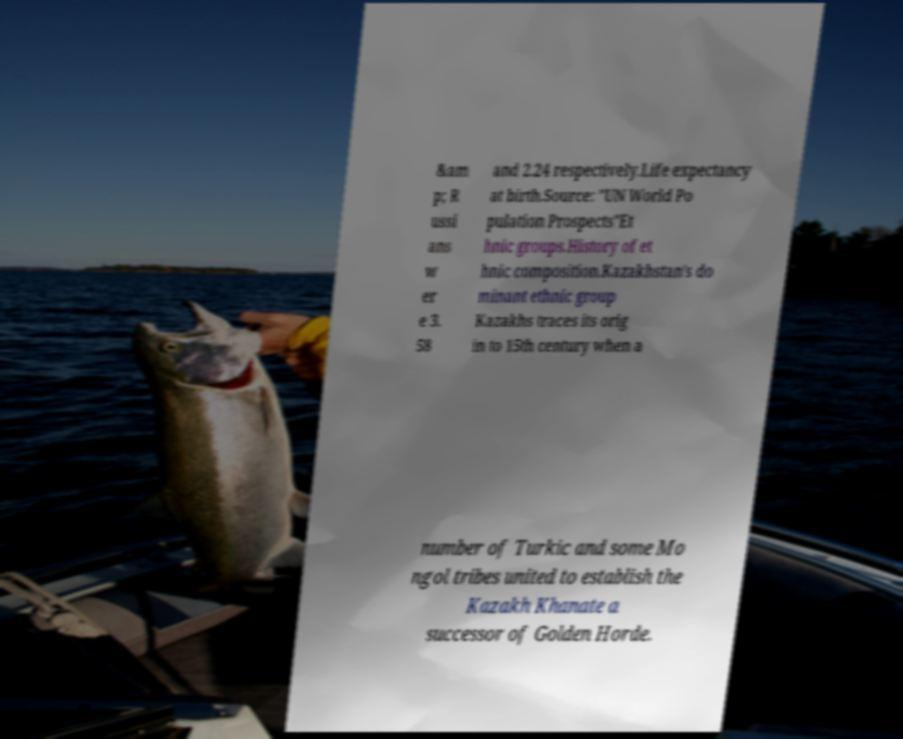What messages or text are displayed in this image? I need them in a readable, typed format. &am p; R ussi ans w er e 3. 58 and 2.24 respectively.Life expectancy at birth.Source: "UN World Po pulation Prospects"Et hnic groups.History of et hnic composition.Kazakhstan's do minant ethnic group Kazakhs traces its orig in to 15th century when a number of Turkic and some Mo ngol tribes united to establish the Kazakh Khanate a successor of Golden Horde. 